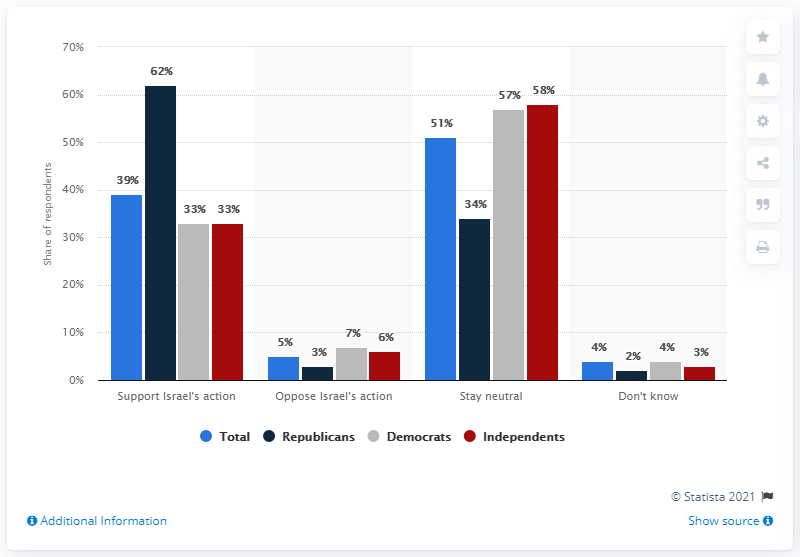List a handful of essential elements in this visual. According to a recent survey, a significant majority of Independents, approximately 60%, oppose Israel's actions in the conflict with Palestine. The ratio between Republicans who support Israel's actions versus those who oppose Israel's actions is approximately 20.66666667. 